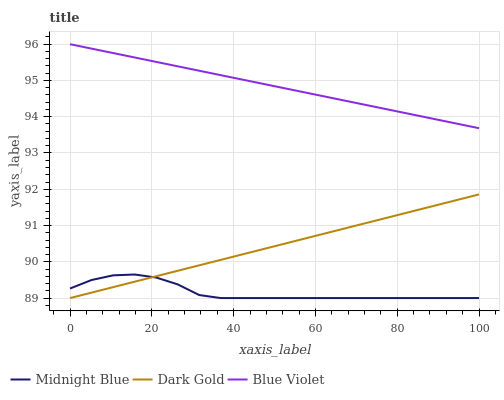Does Midnight Blue have the minimum area under the curve?
Answer yes or no. Yes. Does Blue Violet have the maximum area under the curve?
Answer yes or no. Yes. Does Dark Gold have the minimum area under the curve?
Answer yes or no. No. Does Dark Gold have the maximum area under the curve?
Answer yes or no. No. Is Dark Gold the smoothest?
Answer yes or no. Yes. Is Midnight Blue the roughest?
Answer yes or no. Yes. Is Blue Violet the smoothest?
Answer yes or no. No. Is Blue Violet the roughest?
Answer yes or no. No. Does Midnight Blue have the lowest value?
Answer yes or no. Yes. Does Blue Violet have the lowest value?
Answer yes or no. No. Does Blue Violet have the highest value?
Answer yes or no. Yes. Does Dark Gold have the highest value?
Answer yes or no. No. Is Dark Gold less than Blue Violet?
Answer yes or no. Yes. Is Blue Violet greater than Midnight Blue?
Answer yes or no. Yes. Does Dark Gold intersect Midnight Blue?
Answer yes or no. Yes. Is Dark Gold less than Midnight Blue?
Answer yes or no. No. Is Dark Gold greater than Midnight Blue?
Answer yes or no. No. Does Dark Gold intersect Blue Violet?
Answer yes or no. No. 